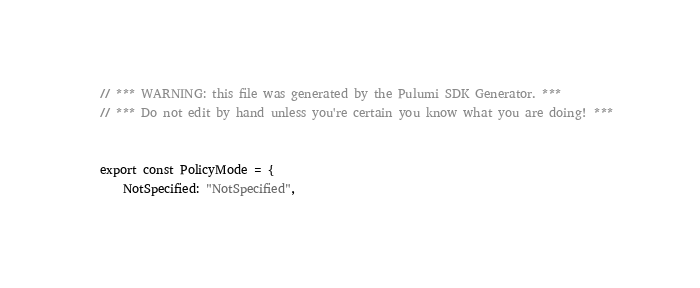Convert code to text. <code><loc_0><loc_0><loc_500><loc_500><_TypeScript_>// *** WARNING: this file was generated by the Pulumi SDK Generator. ***
// *** Do not edit by hand unless you're certain you know what you are doing! ***


export const PolicyMode = {
    NotSpecified: "NotSpecified",</code> 